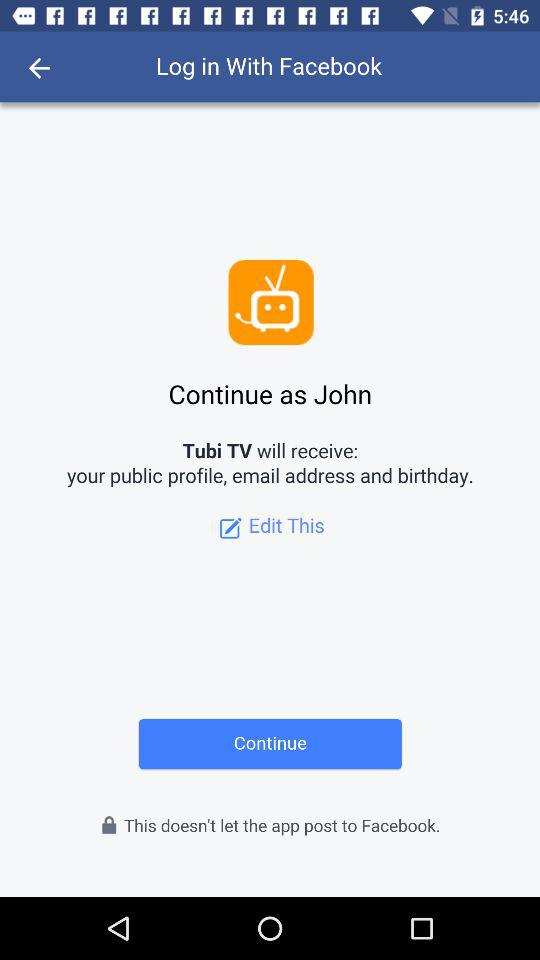What is the user name to continue on the login page? The user name is John. 